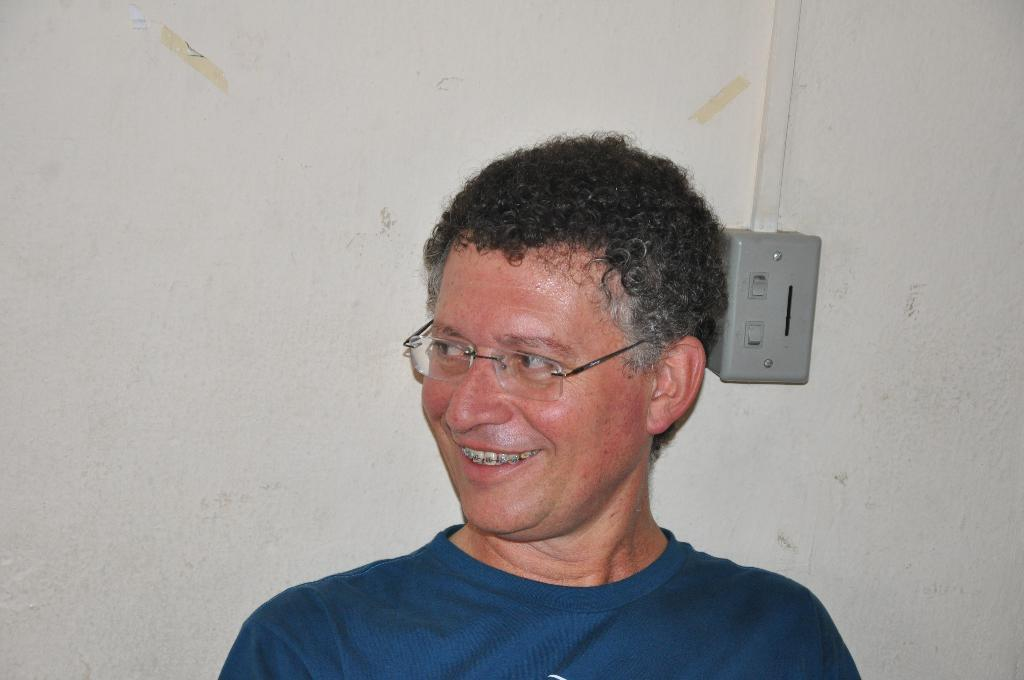Who is present in the image? There is a man in the image. What is the man's facial expression? The man is smiling. What can be seen attached to the wall in the image? There is an object attached to the wall in the image. What is the color of the wall in the image? The wall appears to be white in color. What type of list can be seen on the man's hand in the image? There is no list visible on the man's hand in the image. 